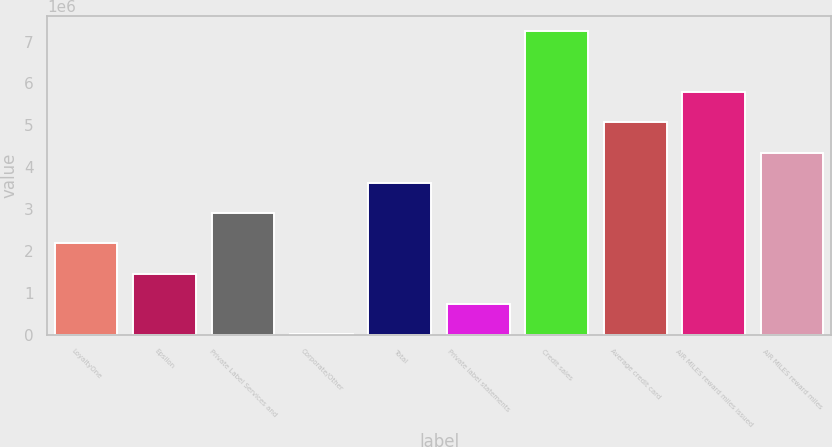Convert chart. <chart><loc_0><loc_0><loc_500><loc_500><bar_chart><fcel>LoyaltyOne<fcel>Epsilon<fcel>Private Label Services and<fcel>Corporate/Other<fcel>Total<fcel>Private label statements<fcel>Credit sales<fcel>Average credit card<fcel>AIR MILES reward miles issued<fcel>AIR MILES reward miles<nl><fcel>2.18421e+06<fcel>1.46161e+06<fcel>2.90681e+06<fcel>16405<fcel>3.62941e+06<fcel>739007<fcel>7.24242e+06<fcel>5.07462e+06<fcel>5.79722e+06<fcel>4.35202e+06<nl></chart> 